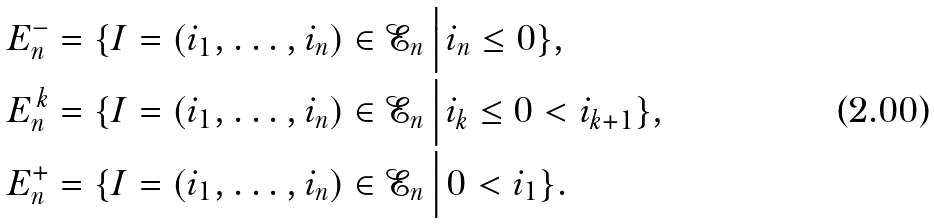<formula> <loc_0><loc_0><loc_500><loc_500>E _ { n } ^ { - } & = \{ I = ( i _ { 1 } , \dots , i _ { n } ) \in \mathcal { E } _ { n } \, \Big | \, i _ { n } \leq 0 \} , \\ E _ { n } ^ { \, k } & = \{ I = ( i _ { 1 } , \dots , i _ { n } ) \in \mathcal { E } _ { n } \, \Big | \, i _ { k } \leq 0 < i _ { k + 1 } \} , \\ E _ { n } ^ { + } & = \{ I = ( i _ { 1 } , \dots , i _ { n } ) \in \mathcal { E } _ { n } \, \Big | \, 0 < i _ { 1 } \} .</formula> 